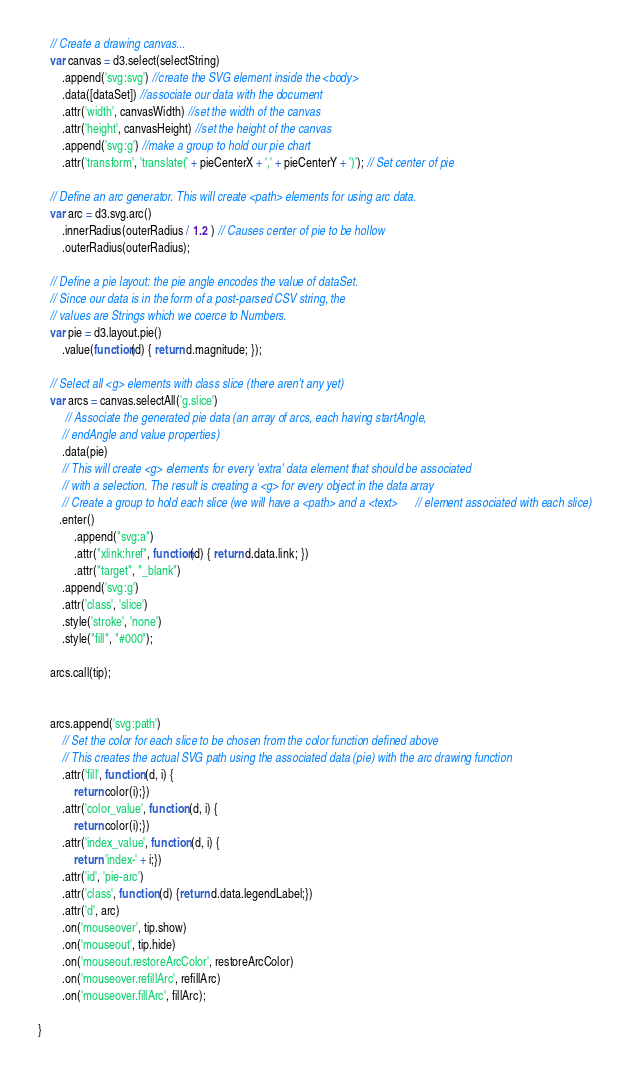<code> <loc_0><loc_0><loc_500><loc_500><_JavaScript_>
    // Create a drawing canvas...
    var canvas = d3.select(selectString)
        .append('svg:svg') //create the SVG element inside the <body>
        .data([dataSet]) //associate our data with the document
        .attr('width', canvasWidth) //set the width of the canvas
        .attr('height', canvasHeight) //set the height of the canvas
        .append('svg:g') //make a group to hold our pie chart
        .attr('transform', 'translate(' + pieCenterX + ',' + pieCenterY + ')'); // Set center of pie

    // Define an arc generator. This will create <path> elements for using arc data.
    var arc = d3.svg.arc()
        .innerRadius(outerRadius / 1.2 ) // Causes center of pie to be hollow
        .outerRadius(outerRadius);

    // Define a pie layout: the pie angle encodes the value of dataSet.
    // Since our data is in the form of a post-parsed CSV string, the
    // values are Strings which we coerce to Numbers.
    var pie = d3.layout.pie()
        .value(function(d) { return d.magnitude; });

    // Select all <g> elements with class slice (there aren't any yet)
    var arcs = canvas.selectAll('g.slice')
         // Associate the generated pie data (an array of arcs, each having startAngle,
        // endAngle and value properties)
        .data(pie)
        // This will create <g> elements for every 'extra' data element that should be associated
        // with a selection. The result is creating a <g> for every object in the data array
        // Create a group to hold each slice (we will have a <path> and a <text>      // element associated with each slice)
	   .enter()
            .append("svg:a")
            .attr("xlink:href", function(d) { return d.data.link; })
            .attr("target", "_blank")
        .append('svg:g')
        .attr('class', 'slice')
        .style('stroke', 'none')
        .style("fill", "#000");
    
    arcs.call(tip);

    
    arcs.append('svg:path')
        // Set the color for each slice to be chosen from the color function defined above
        // This creates the actual SVG path using the associated data (pie) with the arc drawing function
        .attr('fill', function (d, i) {
            return color(i);})
        .attr('color_value', function (d, i) {
            return color(i);})
        .attr('index_value', function (d, i) {
            return 'index-' + i;})
        .attr('id', 'pie-arc')
        .attr('class', function (d) {return d.data.legendLabel;})
        .attr('d', arc)
        .on('mouseover', tip.show)
        .on('mouseout', tip.hide)
        .on('mouseout.restoreArcColor', restoreArcColor)
        .on('mouseover.refillArc', refillArc)
        .on('mouseover.fillArc', fillArc);
    
}</code> 